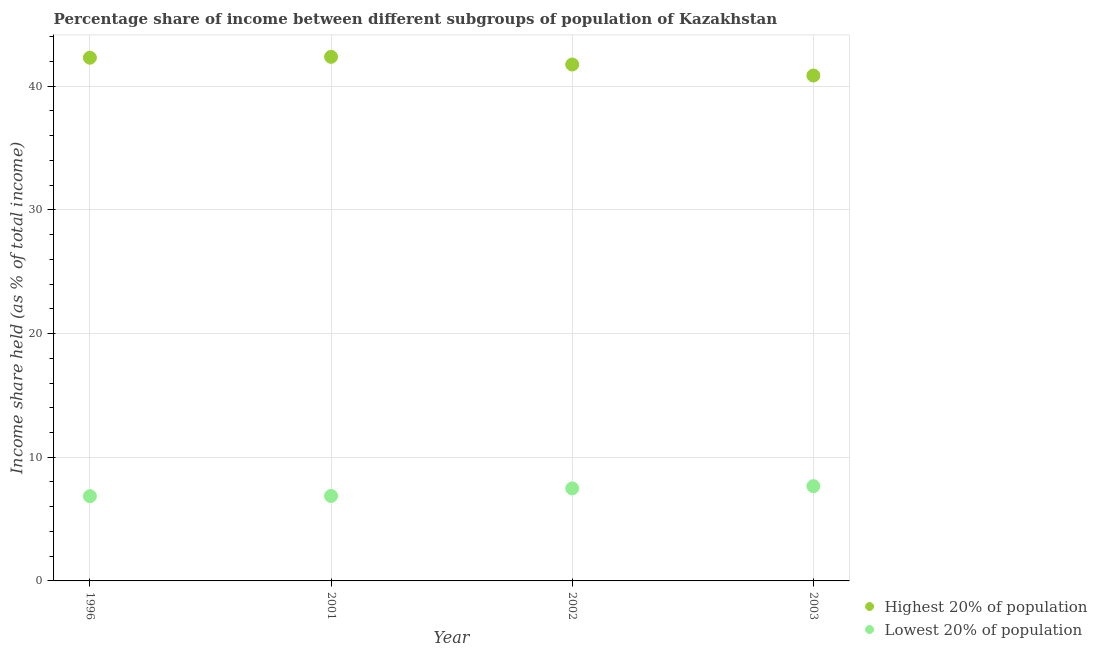What is the income share held by highest 20% of the population in 2001?
Offer a very short reply. 42.37. Across all years, what is the maximum income share held by highest 20% of the population?
Offer a terse response. 42.37. Across all years, what is the minimum income share held by highest 20% of the population?
Your answer should be very brief. 40.86. What is the total income share held by lowest 20% of the population in the graph?
Make the answer very short. 28.86. What is the difference between the income share held by highest 20% of the population in 2001 and that in 2003?
Offer a terse response. 1.51. What is the difference between the income share held by lowest 20% of the population in 2001 and the income share held by highest 20% of the population in 1996?
Make the answer very short. -35.43. What is the average income share held by lowest 20% of the population per year?
Offer a terse response. 7.21. In the year 2003, what is the difference between the income share held by lowest 20% of the population and income share held by highest 20% of the population?
Your answer should be compact. -33.2. What is the ratio of the income share held by lowest 20% of the population in 1996 to that in 2001?
Offer a terse response. 1. Is the income share held by highest 20% of the population in 2001 less than that in 2003?
Offer a very short reply. No. Is the difference between the income share held by lowest 20% of the population in 2002 and 2003 greater than the difference between the income share held by highest 20% of the population in 2002 and 2003?
Give a very brief answer. No. What is the difference between the highest and the second highest income share held by lowest 20% of the population?
Offer a terse response. 0.18. What is the difference between the highest and the lowest income share held by lowest 20% of the population?
Ensure brevity in your answer.  0.81. In how many years, is the income share held by highest 20% of the population greater than the average income share held by highest 20% of the population taken over all years?
Provide a succinct answer. 2. Is the sum of the income share held by lowest 20% of the population in 2002 and 2003 greater than the maximum income share held by highest 20% of the population across all years?
Give a very brief answer. No. Is the income share held by lowest 20% of the population strictly less than the income share held by highest 20% of the population over the years?
Offer a very short reply. Yes. How many dotlines are there?
Give a very brief answer. 2. What is the difference between two consecutive major ticks on the Y-axis?
Provide a short and direct response. 10. Are the values on the major ticks of Y-axis written in scientific E-notation?
Your response must be concise. No. Does the graph contain any zero values?
Ensure brevity in your answer.  No. Does the graph contain grids?
Ensure brevity in your answer.  Yes. Where does the legend appear in the graph?
Your answer should be very brief. Bottom right. What is the title of the graph?
Ensure brevity in your answer.  Percentage share of income between different subgroups of population of Kazakhstan. Does "By country of asylum" appear as one of the legend labels in the graph?
Provide a succinct answer. No. What is the label or title of the Y-axis?
Provide a succinct answer. Income share held (as % of total income). What is the Income share held (as % of total income) of Highest 20% of population in 1996?
Make the answer very short. 42.3. What is the Income share held (as % of total income) of Lowest 20% of population in 1996?
Make the answer very short. 6.85. What is the Income share held (as % of total income) of Highest 20% of population in 2001?
Your answer should be very brief. 42.37. What is the Income share held (as % of total income) of Lowest 20% of population in 2001?
Make the answer very short. 6.87. What is the Income share held (as % of total income) of Highest 20% of population in 2002?
Keep it short and to the point. 41.75. What is the Income share held (as % of total income) in Lowest 20% of population in 2002?
Provide a short and direct response. 7.48. What is the Income share held (as % of total income) in Highest 20% of population in 2003?
Give a very brief answer. 40.86. What is the Income share held (as % of total income) of Lowest 20% of population in 2003?
Ensure brevity in your answer.  7.66. Across all years, what is the maximum Income share held (as % of total income) in Highest 20% of population?
Provide a succinct answer. 42.37. Across all years, what is the maximum Income share held (as % of total income) in Lowest 20% of population?
Offer a terse response. 7.66. Across all years, what is the minimum Income share held (as % of total income) in Highest 20% of population?
Offer a terse response. 40.86. Across all years, what is the minimum Income share held (as % of total income) of Lowest 20% of population?
Your answer should be very brief. 6.85. What is the total Income share held (as % of total income) of Highest 20% of population in the graph?
Offer a very short reply. 167.28. What is the total Income share held (as % of total income) in Lowest 20% of population in the graph?
Make the answer very short. 28.86. What is the difference between the Income share held (as % of total income) of Highest 20% of population in 1996 and that in 2001?
Make the answer very short. -0.07. What is the difference between the Income share held (as % of total income) in Lowest 20% of population in 1996 and that in 2001?
Provide a succinct answer. -0.02. What is the difference between the Income share held (as % of total income) of Highest 20% of population in 1996 and that in 2002?
Give a very brief answer. 0.55. What is the difference between the Income share held (as % of total income) of Lowest 20% of population in 1996 and that in 2002?
Provide a succinct answer. -0.63. What is the difference between the Income share held (as % of total income) of Highest 20% of population in 1996 and that in 2003?
Your response must be concise. 1.44. What is the difference between the Income share held (as % of total income) in Lowest 20% of population in 1996 and that in 2003?
Offer a very short reply. -0.81. What is the difference between the Income share held (as % of total income) in Highest 20% of population in 2001 and that in 2002?
Offer a terse response. 0.62. What is the difference between the Income share held (as % of total income) in Lowest 20% of population in 2001 and that in 2002?
Provide a short and direct response. -0.61. What is the difference between the Income share held (as % of total income) of Highest 20% of population in 2001 and that in 2003?
Offer a terse response. 1.51. What is the difference between the Income share held (as % of total income) in Lowest 20% of population in 2001 and that in 2003?
Offer a terse response. -0.79. What is the difference between the Income share held (as % of total income) in Highest 20% of population in 2002 and that in 2003?
Your response must be concise. 0.89. What is the difference between the Income share held (as % of total income) of Lowest 20% of population in 2002 and that in 2003?
Keep it short and to the point. -0.18. What is the difference between the Income share held (as % of total income) of Highest 20% of population in 1996 and the Income share held (as % of total income) of Lowest 20% of population in 2001?
Keep it short and to the point. 35.43. What is the difference between the Income share held (as % of total income) of Highest 20% of population in 1996 and the Income share held (as % of total income) of Lowest 20% of population in 2002?
Your response must be concise. 34.82. What is the difference between the Income share held (as % of total income) in Highest 20% of population in 1996 and the Income share held (as % of total income) in Lowest 20% of population in 2003?
Offer a very short reply. 34.64. What is the difference between the Income share held (as % of total income) of Highest 20% of population in 2001 and the Income share held (as % of total income) of Lowest 20% of population in 2002?
Offer a very short reply. 34.89. What is the difference between the Income share held (as % of total income) of Highest 20% of population in 2001 and the Income share held (as % of total income) of Lowest 20% of population in 2003?
Give a very brief answer. 34.71. What is the difference between the Income share held (as % of total income) in Highest 20% of population in 2002 and the Income share held (as % of total income) in Lowest 20% of population in 2003?
Your answer should be compact. 34.09. What is the average Income share held (as % of total income) of Highest 20% of population per year?
Offer a very short reply. 41.82. What is the average Income share held (as % of total income) in Lowest 20% of population per year?
Keep it short and to the point. 7.21. In the year 1996, what is the difference between the Income share held (as % of total income) in Highest 20% of population and Income share held (as % of total income) in Lowest 20% of population?
Your answer should be very brief. 35.45. In the year 2001, what is the difference between the Income share held (as % of total income) of Highest 20% of population and Income share held (as % of total income) of Lowest 20% of population?
Give a very brief answer. 35.5. In the year 2002, what is the difference between the Income share held (as % of total income) in Highest 20% of population and Income share held (as % of total income) in Lowest 20% of population?
Your response must be concise. 34.27. In the year 2003, what is the difference between the Income share held (as % of total income) of Highest 20% of population and Income share held (as % of total income) of Lowest 20% of population?
Provide a succinct answer. 33.2. What is the ratio of the Income share held (as % of total income) of Highest 20% of population in 1996 to that in 2002?
Your answer should be compact. 1.01. What is the ratio of the Income share held (as % of total income) of Lowest 20% of population in 1996 to that in 2002?
Your answer should be very brief. 0.92. What is the ratio of the Income share held (as % of total income) of Highest 20% of population in 1996 to that in 2003?
Make the answer very short. 1.04. What is the ratio of the Income share held (as % of total income) in Lowest 20% of population in 1996 to that in 2003?
Keep it short and to the point. 0.89. What is the ratio of the Income share held (as % of total income) in Highest 20% of population in 2001 to that in 2002?
Ensure brevity in your answer.  1.01. What is the ratio of the Income share held (as % of total income) of Lowest 20% of population in 2001 to that in 2002?
Your answer should be compact. 0.92. What is the ratio of the Income share held (as % of total income) of Highest 20% of population in 2001 to that in 2003?
Give a very brief answer. 1.04. What is the ratio of the Income share held (as % of total income) in Lowest 20% of population in 2001 to that in 2003?
Offer a very short reply. 0.9. What is the ratio of the Income share held (as % of total income) of Highest 20% of population in 2002 to that in 2003?
Ensure brevity in your answer.  1.02. What is the ratio of the Income share held (as % of total income) of Lowest 20% of population in 2002 to that in 2003?
Offer a very short reply. 0.98. What is the difference between the highest and the second highest Income share held (as % of total income) in Highest 20% of population?
Your response must be concise. 0.07. What is the difference between the highest and the second highest Income share held (as % of total income) in Lowest 20% of population?
Your response must be concise. 0.18. What is the difference between the highest and the lowest Income share held (as % of total income) in Highest 20% of population?
Offer a terse response. 1.51. What is the difference between the highest and the lowest Income share held (as % of total income) in Lowest 20% of population?
Your answer should be very brief. 0.81. 